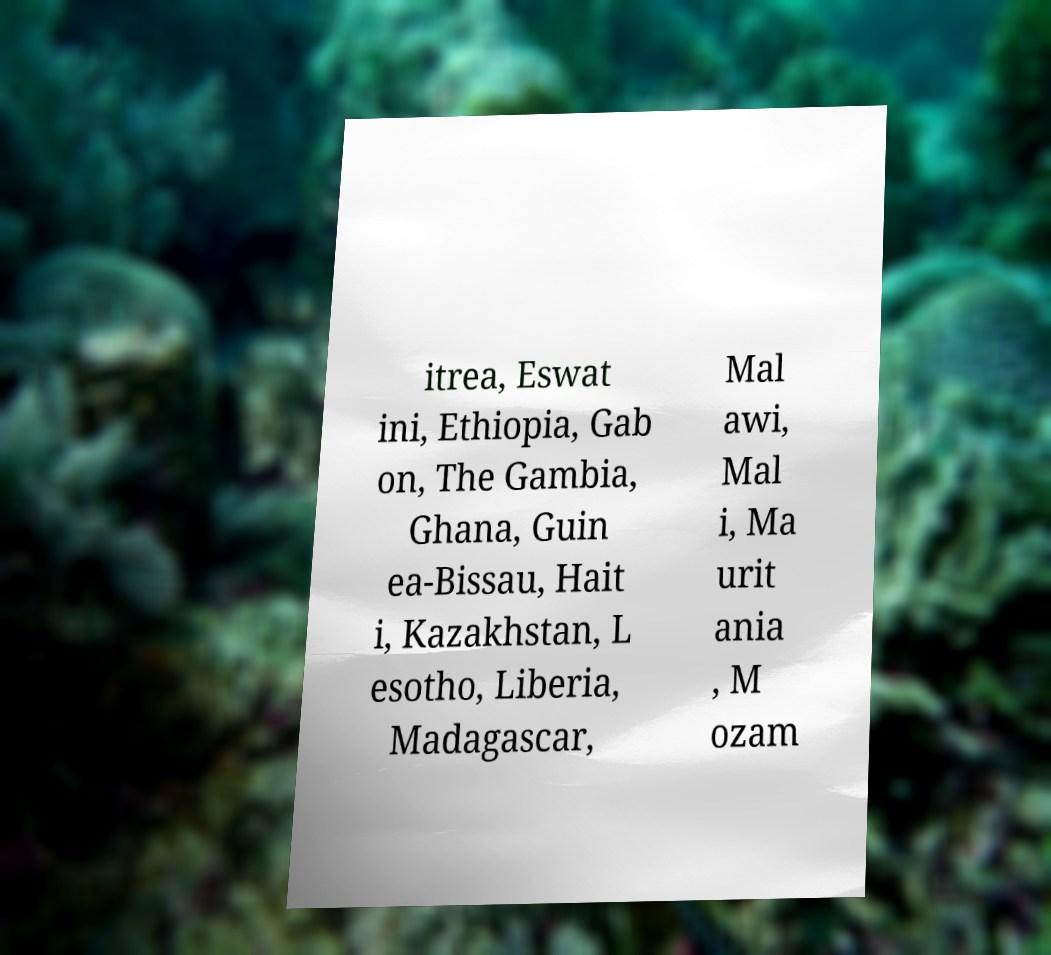There's text embedded in this image that I need extracted. Can you transcribe it verbatim? itrea, Eswat ini, Ethiopia, Gab on, The Gambia, Ghana, Guin ea-Bissau, Hait i, Kazakhstan, L esotho, Liberia, Madagascar, Mal awi, Mal i, Ma urit ania , M ozam 